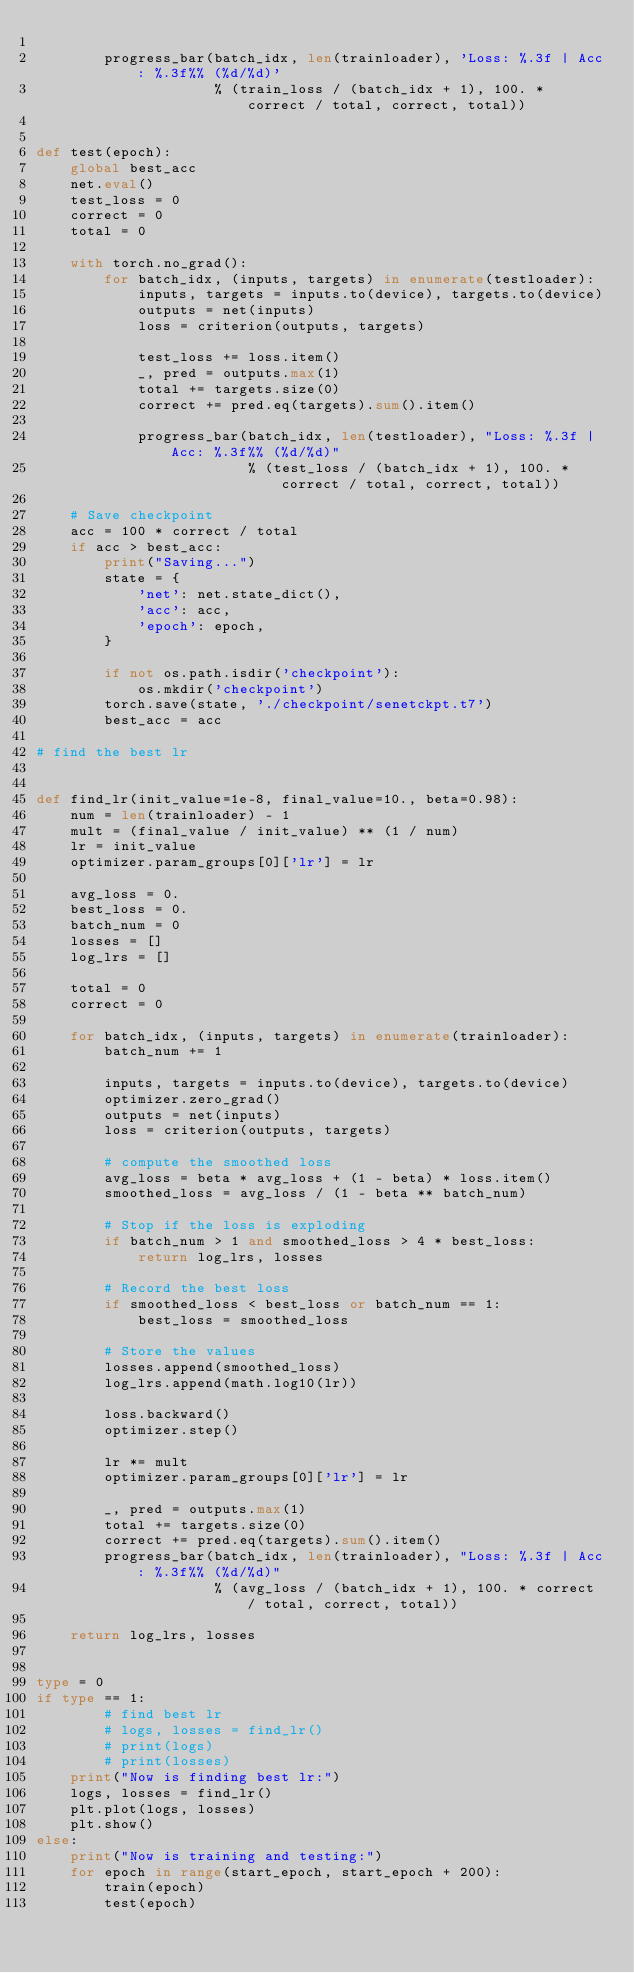Convert code to text. <code><loc_0><loc_0><loc_500><loc_500><_Python_>
        progress_bar(batch_idx, len(trainloader), 'Loss: %.3f | Acc: %.3f%% (%d/%d)'
                     % (train_loss / (batch_idx + 1), 100. * correct / total, correct, total))


def test(epoch):
    global best_acc
    net.eval()
    test_loss = 0
    correct = 0
    total = 0

    with torch.no_grad():
        for batch_idx, (inputs, targets) in enumerate(testloader):
            inputs, targets = inputs.to(device), targets.to(device)
            outputs = net(inputs)
            loss = criterion(outputs, targets)

            test_loss += loss.item()
            _, pred = outputs.max(1)
            total += targets.size(0)
            correct += pred.eq(targets).sum().item()

            progress_bar(batch_idx, len(testloader), "Loss: %.3f | Acc: %.3f%% (%d/%d)"
                         % (test_loss / (batch_idx + 1), 100. * correct / total, correct, total))

    # Save checkpoint
    acc = 100 * correct / total
    if acc > best_acc:
        print("Saving...")
        state = {
            'net': net.state_dict(),
            'acc': acc,
            'epoch': epoch,
        }

        if not os.path.isdir('checkpoint'):
            os.mkdir('checkpoint')
        torch.save(state, './checkpoint/senetckpt.t7')
        best_acc = acc

# find the best lr


def find_lr(init_value=1e-8, final_value=10., beta=0.98):
    num = len(trainloader) - 1
    mult = (final_value / init_value) ** (1 / num)
    lr = init_value
    optimizer.param_groups[0]['lr'] = lr

    avg_loss = 0.
    best_loss = 0.
    batch_num = 0
    losses = []
    log_lrs = []

    total = 0
    correct = 0

    for batch_idx, (inputs, targets) in enumerate(trainloader):
        batch_num += 1

        inputs, targets = inputs.to(device), targets.to(device)
        optimizer.zero_grad()
        outputs = net(inputs)
        loss = criterion(outputs, targets)

        # compute the smoothed loss
        avg_loss = beta * avg_loss + (1 - beta) * loss.item()
        smoothed_loss = avg_loss / (1 - beta ** batch_num)

        # Stop if the loss is exploding
        if batch_num > 1 and smoothed_loss > 4 * best_loss:
            return log_lrs, losses

        # Record the best loss
        if smoothed_loss < best_loss or batch_num == 1:
            best_loss = smoothed_loss

        # Store the values
        losses.append(smoothed_loss)
        log_lrs.append(math.log10(lr))

        loss.backward()
        optimizer.step()

        lr *= mult
        optimizer.param_groups[0]['lr'] = lr

        _, pred = outputs.max(1)
        total += targets.size(0)
        correct += pred.eq(targets).sum().item()
        progress_bar(batch_idx, len(trainloader), "Loss: %.3f | Acc: %.3f%% (%d/%d)"
                     % (avg_loss / (batch_idx + 1), 100. * correct / total, correct, total))

    return log_lrs, losses


type = 0
if type == 1:
        # find best lr
        # logs, losses = find_lr()
        # print(logs)
        # print(losses)
    print("Now is finding best lr:")
    logs, losses = find_lr()
    plt.plot(logs, losses)
    plt.show()
else:
    print("Now is training and testing:")
    for epoch in range(start_epoch, start_epoch + 200):
        train(epoch)
        test(epoch)
</code> 